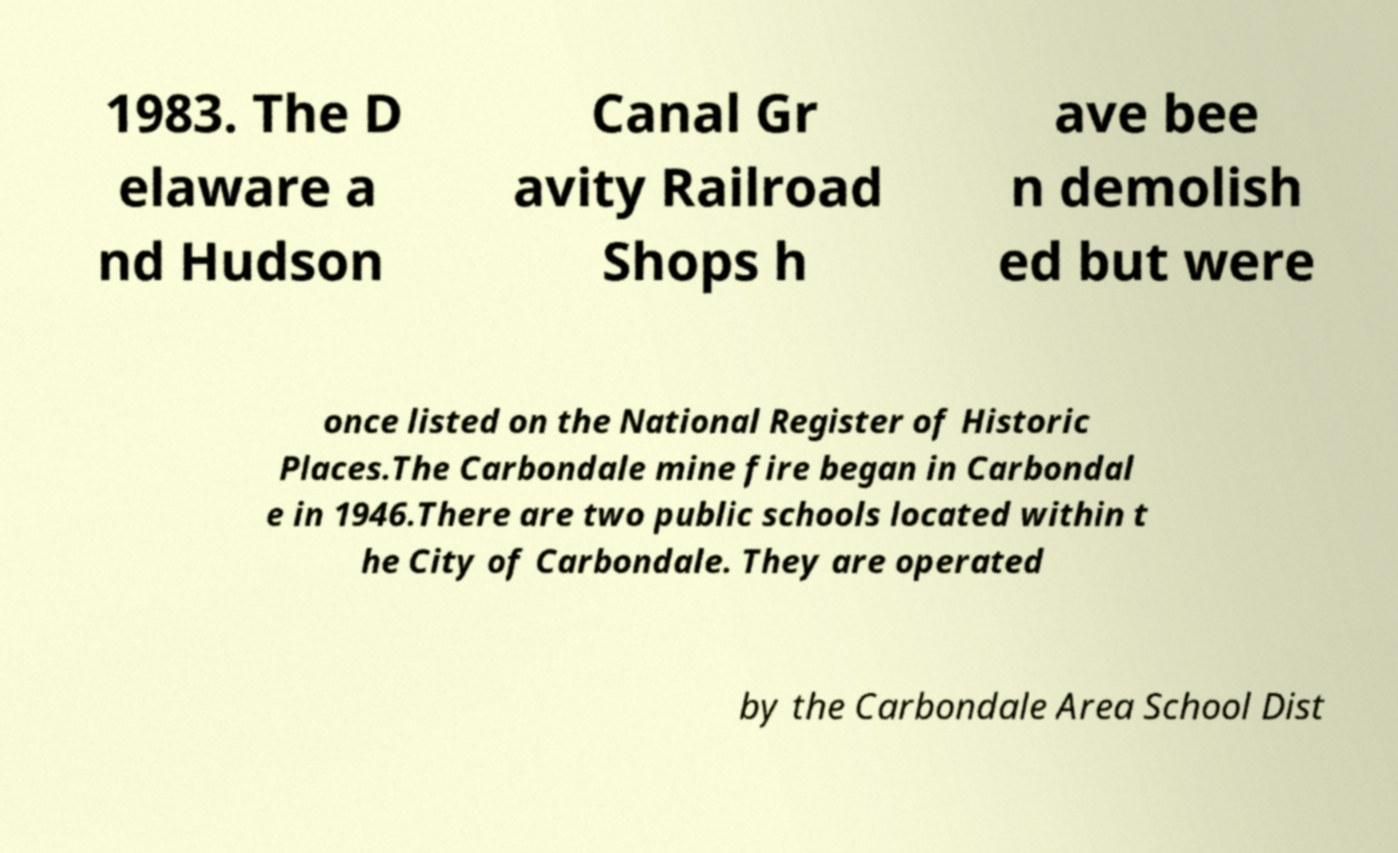For documentation purposes, I need the text within this image transcribed. Could you provide that? 1983. The D elaware a nd Hudson Canal Gr avity Railroad Shops h ave bee n demolish ed but were once listed on the National Register of Historic Places.The Carbondale mine fire began in Carbondal e in 1946.There are two public schools located within t he City of Carbondale. They are operated by the Carbondale Area School Dist 